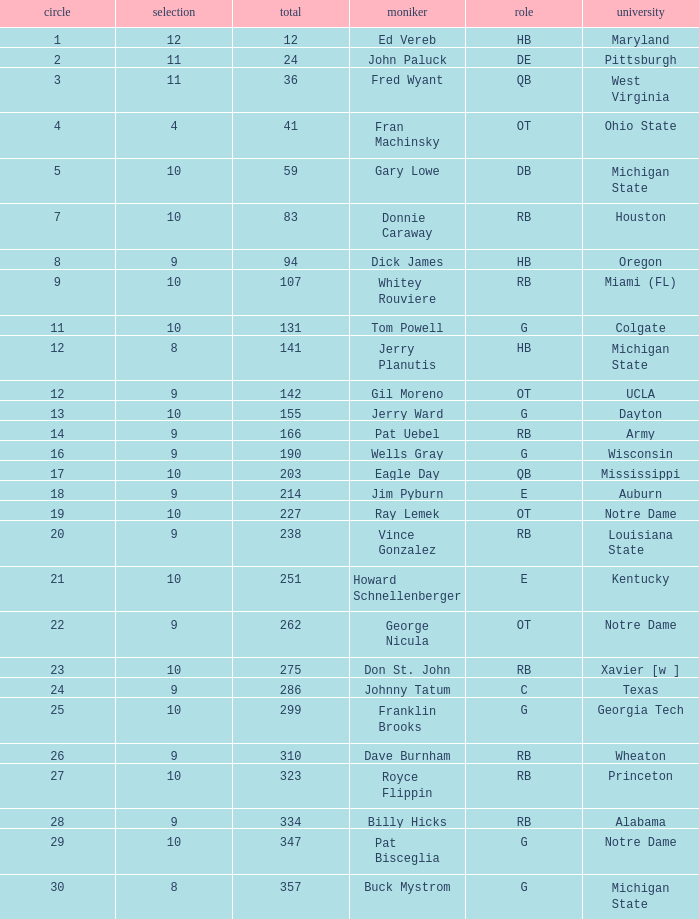What is the sum of rounds that has a pick of 9 and is named jim pyburn? 18.0. 